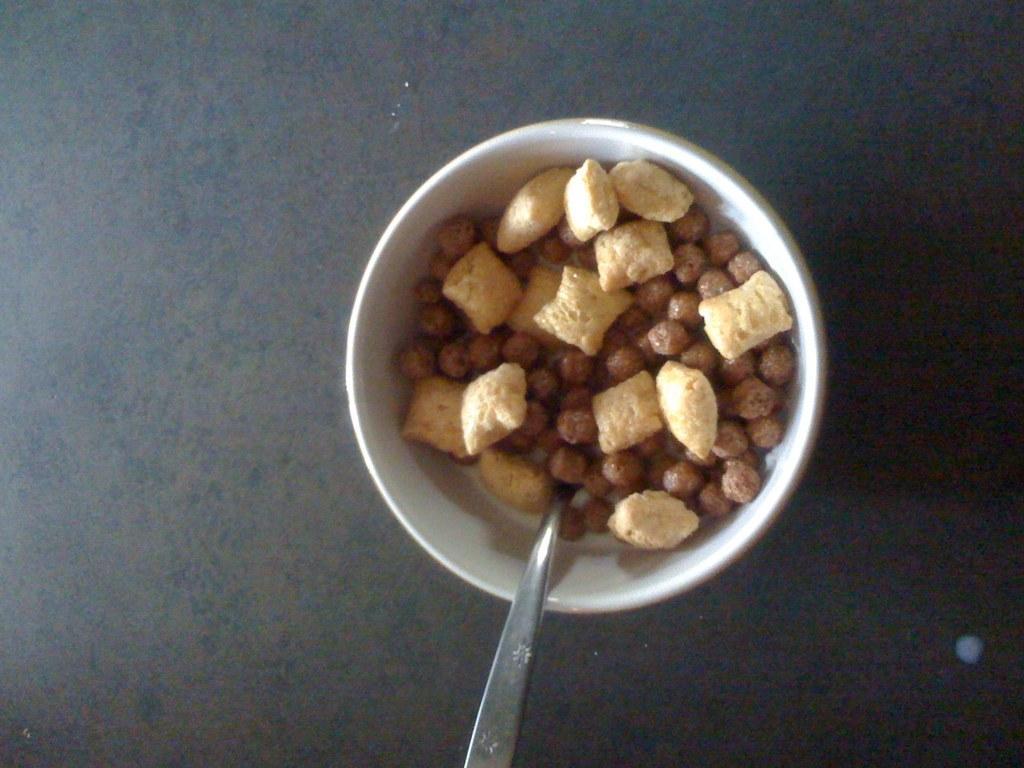How would you summarize this image in a sentence or two? This image consists of a bowl in which there are nuts along with a spoon is kept on the table. 